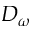Convert formula to latex. <formula><loc_0><loc_0><loc_500><loc_500>D _ { \omega }</formula> 